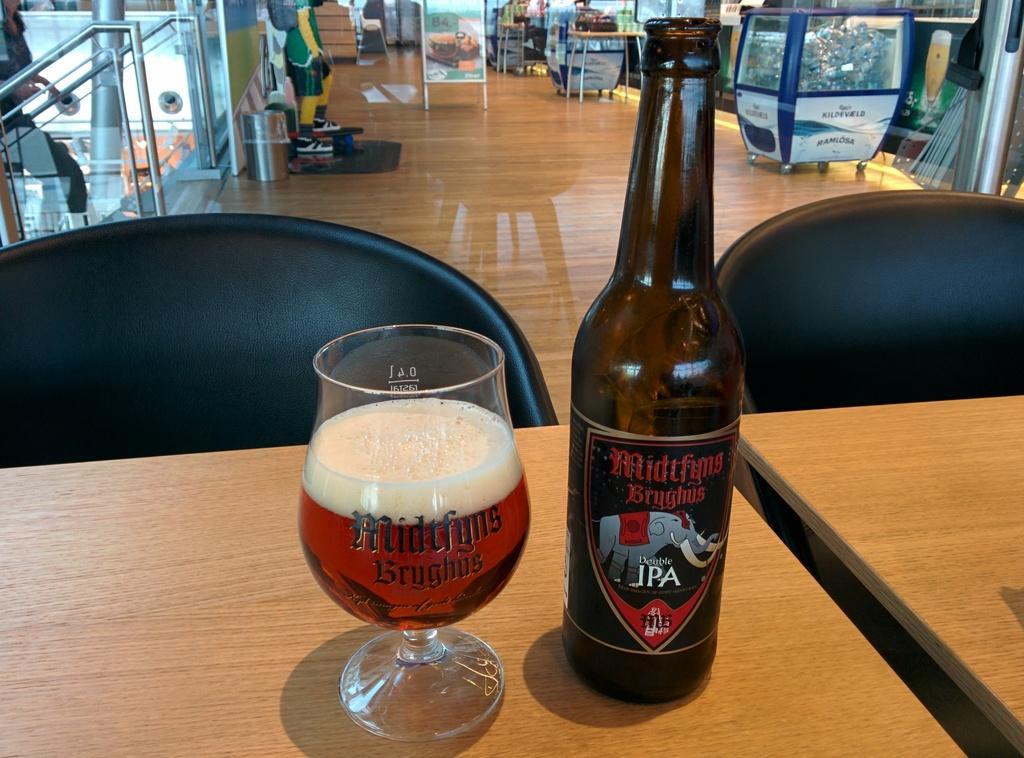<image>
Present a compact description of the photo's key features. a glass and bottle of Midtfyns Brughus IPA 